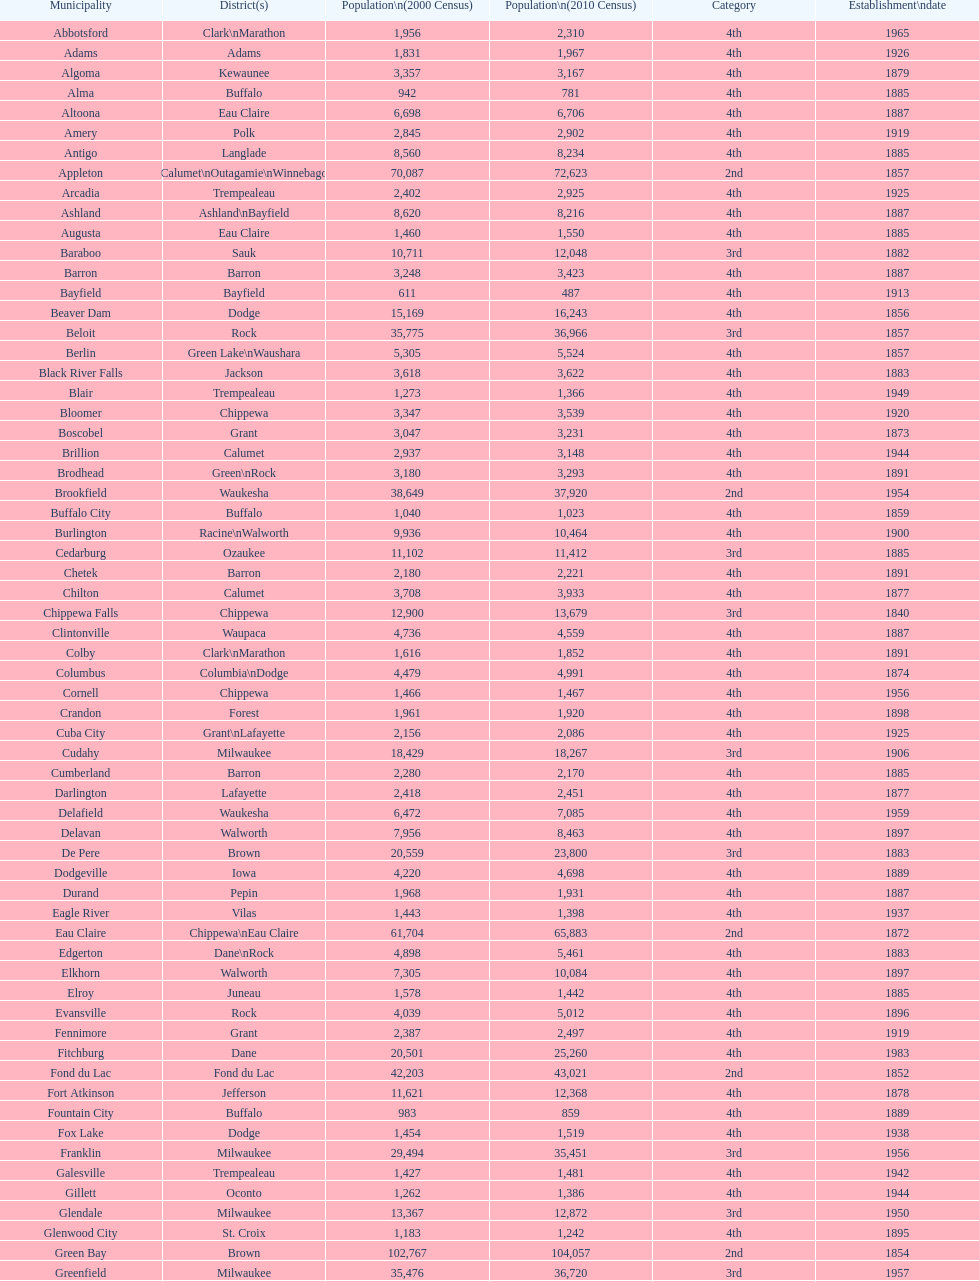Could you help me parse every detail presented in this table? {'header': ['Municipality', 'District(s)', 'Population\\n(2000 Census)', 'Population\\n(2010 Census)', 'Category', 'Establishment\\ndate'], 'rows': [['Abbotsford', 'Clark\\nMarathon', '1,956', '2,310', '4th', '1965'], ['Adams', 'Adams', '1,831', '1,967', '4th', '1926'], ['Algoma', 'Kewaunee', '3,357', '3,167', '4th', '1879'], ['Alma', 'Buffalo', '942', '781', '4th', '1885'], ['Altoona', 'Eau Claire', '6,698', '6,706', '4th', '1887'], ['Amery', 'Polk', '2,845', '2,902', '4th', '1919'], ['Antigo', 'Langlade', '8,560', '8,234', '4th', '1885'], ['Appleton', 'Calumet\\nOutagamie\\nWinnebago', '70,087', '72,623', '2nd', '1857'], ['Arcadia', 'Trempealeau', '2,402', '2,925', '4th', '1925'], ['Ashland', 'Ashland\\nBayfield', '8,620', '8,216', '4th', '1887'], ['Augusta', 'Eau Claire', '1,460', '1,550', '4th', '1885'], ['Baraboo', 'Sauk', '10,711', '12,048', '3rd', '1882'], ['Barron', 'Barron', '3,248', '3,423', '4th', '1887'], ['Bayfield', 'Bayfield', '611', '487', '4th', '1913'], ['Beaver Dam', 'Dodge', '15,169', '16,243', '4th', '1856'], ['Beloit', 'Rock', '35,775', '36,966', '3rd', '1857'], ['Berlin', 'Green Lake\\nWaushara', '5,305', '5,524', '4th', '1857'], ['Black River Falls', 'Jackson', '3,618', '3,622', '4th', '1883'], ['Blair', 'Trempealeau', '1,273', '1,366', '4th', '1949'], ['Bloomer', 'Chippewa', '3,347', '3,539', '4th', '1920'], ['Boscobel', 'Grant', '3,047', '3,231', '4th', '1873'], ['Brillion', 'Calumet', '2,937', '3,148', '4th', '1944'], ['Brodhead', 'Green\\nRock', '3,180', '3,293', '4th', '1891'], ['Brookfield', 'Waukesha', '38,649', '37,920', '2nd', '1954'], ['Buffalo City', 'Buffalo', '1,040', '1,023', '4th', '1859'], ['Burlington', 'Racine\\nWalworth', '9,936', '10,464', '4th', '1900'], ['Cedarburg', 'Ozaukee', '11,102', '11,412', '3rd', '1885'], ['Chetek', 'Barron', '2,180', '2,221', '4th', '1891'], ['Chilton', 'Calumet', '3,708', '3,933', '4th', '1877'], ['Chippewa Falls', 'Chippewa', '12,900', '13,679', '3rd', '1840'], ['Clintonville', 'Waupaca', '4,736', '4,559', '4th', '1887'], ['Colby', 'Clark\\nMarathon', '1,616', '1,852', '4th', '1891'], ['Columbus', 'Columbia\\nDodge', '4,479', '4,991', '4th', '1874'], ['Cornell', 'Chippewa', '1,466', '1,467', '4th', '1956'], ['Crandon', 'Forest', '1,961', '1,920', '4th', '1898'], ['Cuba City', 'Grant\\nLafayette', '2,156', '2,086', '4th', '1925'], ['Cudahy', 'Milwaukee', '18,429', '18,267', '3rd', '1906'], ['Cumberland', 'Barron', '2,280', '2,170', '4th', '1885'], ['Darlington', 'Lafayette', '2,418', '2,451', '4th', '1877'], ['Delafield', 'Waukesha', '6,472', '7,085', '4th', '1959'], ['Delavan', 'Walworth', '7,956', '8,463', '4th', '1897'], ['De Pere', 'Brown', '20,559', '23,800', '3rd', '1883'], ['Dodgeville', 'Iowa', '4,220', '4,698', '4th', '1889'], ['Durand', 'Pepin', '1,968', '1,931', '4th', '1887'], ['Eagle River', 'Vilas', '1,443', '1,398', '4th', '1937'], ['Eau Claire', 'Chippewa\\nEau Claire', '61,704', '65,883', '2nd', '1872'], ['Edgerton', 'Dane\\nRock', '4,898', '5,461', '4th', '1883'], ['Elkhorn', 'Walworth', '7,305', '10,084', '4th', '1897'], ['Elroy', 'Juneau', '1,578', '1,442', '4th', '1885'], ['Evansville', 'Rock', '4,039', '5,012', '4th', '1896'], ['Fennimore', 'Grant', '2,387', '2,497', '4th', '1919'], ['Fitchburg', 'Dane', '20,501', '25,260', '4th', '1983'], ['Fond du Lac', 'Fond du Lac', '42,203', '43,021', '2nd', '1852'], ['Fort Atkinson', 'Jefferson', '11,621', '12,368', '4th', '1878'], ['Fountain City', 'Buffalo', '983', '859', '4th', '1889'], ['Fox Lake', 'Dodge', '1,454', '1,519', '4th', '1938'], ['Franklin', 'Milwaukee', '29,494', '35,451', '3rd', '1956'], ['Galesville', 'Trempealeau', '1,427', '1,481', '4th', '1942'], ['Gillett', 'Oconto', '1,262', '1,386', '4th', '1944'], ['Glendale', 'Milwaukee', '13,367', '12,872', '3rd', '1950'], ['Glenwood City', 'St. Croix', '1,183', '1,242', '4th', '1895'], ['Green Bay', 'Brown', '102,767', '104,057', '2nd', '1854'], ['Greenfield', 'Milwaukee', '35,476', '36,720', '3rd', '1957'], ['Green Lake', 'Green Lake', '1,100', '960', '4th', '1962'], ['Greenwood', 'Clark', '1,079', '1,026', '4th', '1891'], ['Hartford', 'Dodge\\nWashington', '10,905', '14,223', '3rd', '1883'], ['Hayward', 'Sawyer', '2,129', '2,318', '4th', '1915'], ['Hillsboro', 'Vernon', '1,302', '1,417', '4th', '1885'], ['Horicon', 'Dodge', '3,775', '3,655', '4th', '1897'], ['Hudson', 'St. Croix', '8,775', '12,719', '4th', '1858'], ['Hurley', 'Iron', '1,818', '1,547', '4th', '1918'], ['Independence', 'Trempealeau', '1,244', '1,336', '4th', '1942'], ['Janesville', 'Rock', '59,498', '63,575', '2nd', '1853'], ['Jefferson', 'Jefferson', '7,338', '7,973', '4th', '1878'], ['Juneau', 'Dodge', '2,485', '2,814', '4th', '1887'], ['Kaukauna', 'Outagamie', '12,983', '15,462', '3rd', '1885'], ['Kenosha', 'Kenosha', '90,352', '99,218', '2nd', '1850'], ['Kewaunee', 'Kewaunee', '2,806', '2,952', '4th', '1883'], ['Kiel', 'Calumet\\nManitowoc', '3,450', '3,738', '4th', '1920'], ['La Crosse', 'La Crosse', '51,818', '51,320', '2nd', '1856'], ['Ladysmith', 'Rusk', '3,932', '3,414', '4th', '1905'], ['Lake Geneva', 'Walworth', '7,148', '7,651', '4th', '1883'], ['Lake Mills', 'Jefferson', '4,843', '5,708', '4th', '1905'], ['Lancaster', 'Grant', '4,070', '3,868', '4th', '1878'], ['Lodi', 'Columbia', '2,882', '3,050', '4th', '1941'], ['Loyal', 'Clark', '1,308', '1,261', '4th', '1948'], ['Madison', 'Dane', '208,054', '233,209', '2nd', '1856'], ['Manawa', 'Waupaca', '1,330', '1,371', '4th', '1954'], ['Manitowoc', 'Manitowoc', '34,053', '33,736', '3rd', '1870'], ['Marinette', 'Marinette', '11,749', '10,968', '3rd', '1887'], ['Marion', 'Shawano\\nWaupaca', '1,297', '1,260', '4th', '1898'], ['Markesan', 'Green Lake', '1,396', '1,476', '4th', '1959'], ['Marshfield', 'Marathon\\nWood', '18,800', '19,118', '3rd', '1883'], ['Mauston', 'Juneau', '3,740', '4,423', '4th', '1883'], ['Mayville', 'Dodge', '4,902', '5,154', '4th', '1885'], ['Medford', 'Taylor', '4,350', '4,326', '4th', '1889'], ['Mellen', 'Ashland', '845', '731', '4th', '1907'], ['Menasha', 'Calumet\\nWinnebago', '16,331', '17,353', '3rd', '1874'], ['Menomonie', 'Dunn', '14,937', '16,264', '4th', '1882'], ['Mequon', 'Ozaukee', '22,643', '23,132', '4th', '1957'], ['Merrill', 'Lincoln', '10,146', '9,661', '4th', '1883'], ['Middleton', 'Dane', '15,770', '17,442', '3rd', '1963'], ['Milton', 'Rock', '5,132', '5,546', '4th', '1969'], ['Milwaukee', 'Milwaukee\\nWashington\\nWaukesha', '596,974', '594,833', '1st', '1846'], ['Mineral Point', 'Iowa', '2,617', '2,487', '4th', '1857'], ['Mondovi', 'Buffalo', '2,634', '2,777', '4th', '1889'], ['Monona', 'Dane', '8,018', '7,533', '4th', '1969'], ['Monroe', 'Green', '10,843', '10,827', '4th', '1882'], ['Montello', 'Marquette', '1,397', '1,495', '4th', '1938'], ['Montreal', 'Iron', '838', '807', '4th', '1924'], ['Mosinee', 'Marathon', '4,063', '3,988', '4th', '1931'], ['Muskego', 'Waukesha', '21,397', '24,135', '3rd', '1964'], ['Neenah', 'Winnebago', '24,507', '25,501', '3rd', '1873'], ['Neillsville', 'Clark', '2,731', '2,463', '4th', '1882'], ['Nekoosa', 'Wood', '2,590', '2,580', '4th', '1926'], ['New Berlin', 'Waukesha', '38,220', '39,584', '3rd', '1959'], ['New Holstein', 'Calumet', '3,301', '3,236', '4th', '1889'], ['New Lisbon', 'Juneau', '1,436', '2,554', '4th', '1889'], ['New London', 'Outagamie\\nWaupaca', '7,085', '7,295', '4th', '1877'], ['New Richmond', 'St. Croix', '6,310', '8,375', '4th', '1885'], ['Niagara', 'Marinette', '1,880', '1,624', '4th', '1992'], ['Oak Creek', 'Milwaukee', '28,456', '34,451', '3rd', '1955'], ['Oconomowoc', 'Waukesha', '12,382', '15,712', '3rd', '1875'], ['Oconto', 'Oconto', '4,708', '4,513', '4th', '1869'], ['Oconto Falls', 'Oconto', '2,843', '2,891', '4th', '1919'], ['Omro', 'Winnebago', '3,177', '3,517', '4th', '1944'], ['Onalaska', 'La Crosse', '14,839', '17,736', '4th', '1887'], ['Oshkosh', 'Winnebago', '62,916', '66,083', '2nd', '1853'], ['Osseo', 'Trempealeau', '1,669', '1,701', '4th', '1941'], ['Owen', 'Clark', '936', '940', '4th', '1925'], ['Park Falls', 'Price', '2,739', '2,462', '4th', '1912'], ['Peshtigo', 'Marinette', '3,474', '3,502', '4th', '1903'], ['Pewaukee', 'Waukesha', '11,783', '13,195', '3rd', '1999'], ['Phillips', 'Price', '1,675', '1,478', '4th', '1891'], ['Pittsville', 'Wood', '866', '874', '4th', '1887'], ['Platteville', 'Grant', '9,989', '11,224', '4th', '1876'], ['Plymouth', 'Sheboygan', '7,781', '8,445', '4th', '1877'], ['Port Washington', 'Ozaukee', '10,467', '11,250', '4th', '1882'], ['Portage', 'Columbia', '9,728', '10,324', '4th', '1854'], ['Prairie du Chien', 'Crawford', '6,018', '5,911', '4th', '1872'], ['Prescott', 'Pierce', '3,764', '4,258', '4th', '1857'], ['Princeton', 'Green Lake', '1,504', '1,214', '4th', '1920'], ['Racine', 'Racine', '81,855', '78,860', '2nd', '1848'], ['Reedsburg', 'Sauk', '7,827', '10,014', '4th', '1887'], ['Rhinelander', 'Oneida', '7,735', '7,798', '4th', '1894'], ['Rice Lake', 'Barron', '8,312', '8,438', '4th', '1887'], ['Richland Center', 'Richland', '5,114', '5,184', '4th', '1887'], ['Ripon', 'Fond du Lac', '7,450', '7,733', '4th', '1858'], ['River Falls', 'Pierce\\nSt. Croix', '12,560', '15,000', '3rd', '1875'], ['St. Croix Falls', 'Polk', '2,033', '2,133', '4th', '1958'], ['St. Francis', 'Milwaukee', '8,662', '9,365', '4th', '1951'], ['Schofield', 'Marathon', '2,117', '2,169', '4th', '1951'], ['Seymour', 'Outagamie', '3,335', '3,451', '4th', '1879'], ['Shawano', 'Shawano', '8,298', '9,305', '4th', '1874'], ['Sheboygan', 'Sheboygan', '50,792', '49,288', '2nd', '1853'], ['Sheboygan Falls', 'Sheboygan', '6,772', '7,775', '4th', '1913'], ['Shell Lake', 'Washburn', '1,309', '1,347', '4th', '1961'], ['Shullsburg', 'Lafayette', '1,246', '1,226', '4th', '1889'], ['South Milwaukee', 'Milwaukee', '21,256', '21,156', '4th', '1897'], ['Sparta', 'Monroe', '8,648', '9,522', '4th', '1883'], ['Spooner', 'Washburn', '2,653', '2,682', '4th', '1909'], ['Stanley', 'Chippewa\\nClark', '1,898', '3,608', '4th', '1898'], ['Stevens Point', 'Portage', '24,551', '26,717', '3rd', '1858'], ['Stoughton', 'Dane', '12,354', '12,611', '4th', '1882'], ['Sturgeon Bay', 'Door', '9,437', '9,144', '4th', '1883'], ['Sun Prairie', 'Dane', '20,369', '29,364', '3rd', '1958'], ['Superior', 'Douglas', '27,368', '27,244', '2nd', '1858'], ['Thorp', 'Clark', '1,536', '1,621', '4th', '1948'], ['Tomah', 'Monroe', '8,419', '9,093', '4th', '1883'], ['Tomahawk', 'Lincoln', '3,770', '3,397', '4th', '1891'], ['Two Rivers', 'Manitowoc', '12,639', '11,712', '3rd', '1878'], ['Verona', 'Dane', '7,052', '10,619', '4th', '1977'], ['Viroqua', 'Vernon', '4,335', '5,079', '4th', '1885'], ['Washburn', 'Bayfield', '2,280', '2,117', '4th', '1904'], ['Waterloo', 'Jefferson', '3,259', '3,333', '4th', '1962'], ['Watertown', 'Dodge\\nJefferson', '21,598', '23,861', '3rd', '1853'], ['Waukesha', 'Waukesha', '64,825', '70,718', '2nd', '1895'], ['Waupaca', 'Waupaca', '5,676', '6,069', '4th', '1878'], ['Waupun', 'Dodge\\nFond du Lac', '10,944', '11,340', '4th', '1878'], ['Wausau', 'Marathon', '38,426', '39,106', '3rd', '1872'], ['Wautoma', 'Waushara', '1,998', '2,218', '4th', '1901'], ['Wauwatosa', 'Milwaukee', '47,271', '46,396', '2nd', '1897'], ['West Allis', 'Milwaukee', '61,254', '60,411', '2nd', '1906'], ['West Bend', 'Washington', '28,152', '31,078', '3rd', '1885'], ['Westby', 'Vernon', '2,045', '2,200', '4th', '1920'], ['Weyauwega', 'Waupaca', '1,806', '1,900', '4th', '1939'], ['Whitehall', 'Trempealeau', '1,651', '1,558', '4th', '1941'], ['Whitewater', 'Jefferson\\nWalworth', '13,437', '14,390', '4th', '1885'], ['Wisconsin Dells', 'Adams\\nColumbia\\nJuneau\\nSauk', '2,418', '2,678', '4th', '1925'], ['Wisconsin Rapids', 'Wood', '18,435', '18,367', '3rd', '1869']]} County has altoona and augusta? Eau Claire. 